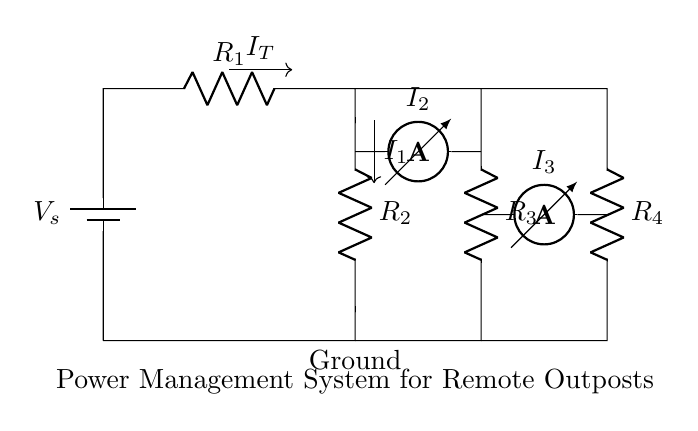What is the total current entering the circuit? The total current entering the circuit is represented as I_T, which indicates the sum of the currents flowing into the circuit from the battery.
Answer: I_T What are the resistances in the circuit? The circuit contains four resistors labeled as R_1, R_2, R_3, and R_4, each representing different resistance values.
Answer: R_1, R_2, R_3, R_4 How is the current divided among the resistors? The current is divided between R_2 and the combination of R_3 and R_4, following the principles of a current divider, where each resistor gets a portion of the total current based on its resistance.
Answer: Yes What is the relationship between I_1 and I_T? I_1 is the current flowing through R_2, which can be calculated using the formula: I_1 = I_T * (R_total / R_2), where R_total is the equivalent resistance of R_3 and R_4 in parallel with R_2.
Answer: I_1 = I_T * (R_total / R_2) Which resistors are in parallel in this circuit? R_3 and R_4 are connected in parallel, meaning the voltage across both resistors is the same, and they share the total current I_T based on their individual resistances.
Answer: R_3, R_4 What happens to the total current if resistance R_2 increases? If resistance R_2 increases, the current I_1 through R_2 decreases according to the current divider rule, resulting in a smaller portion of the total current I_T being allocated to R_2.
Answer: I_1 decreases 